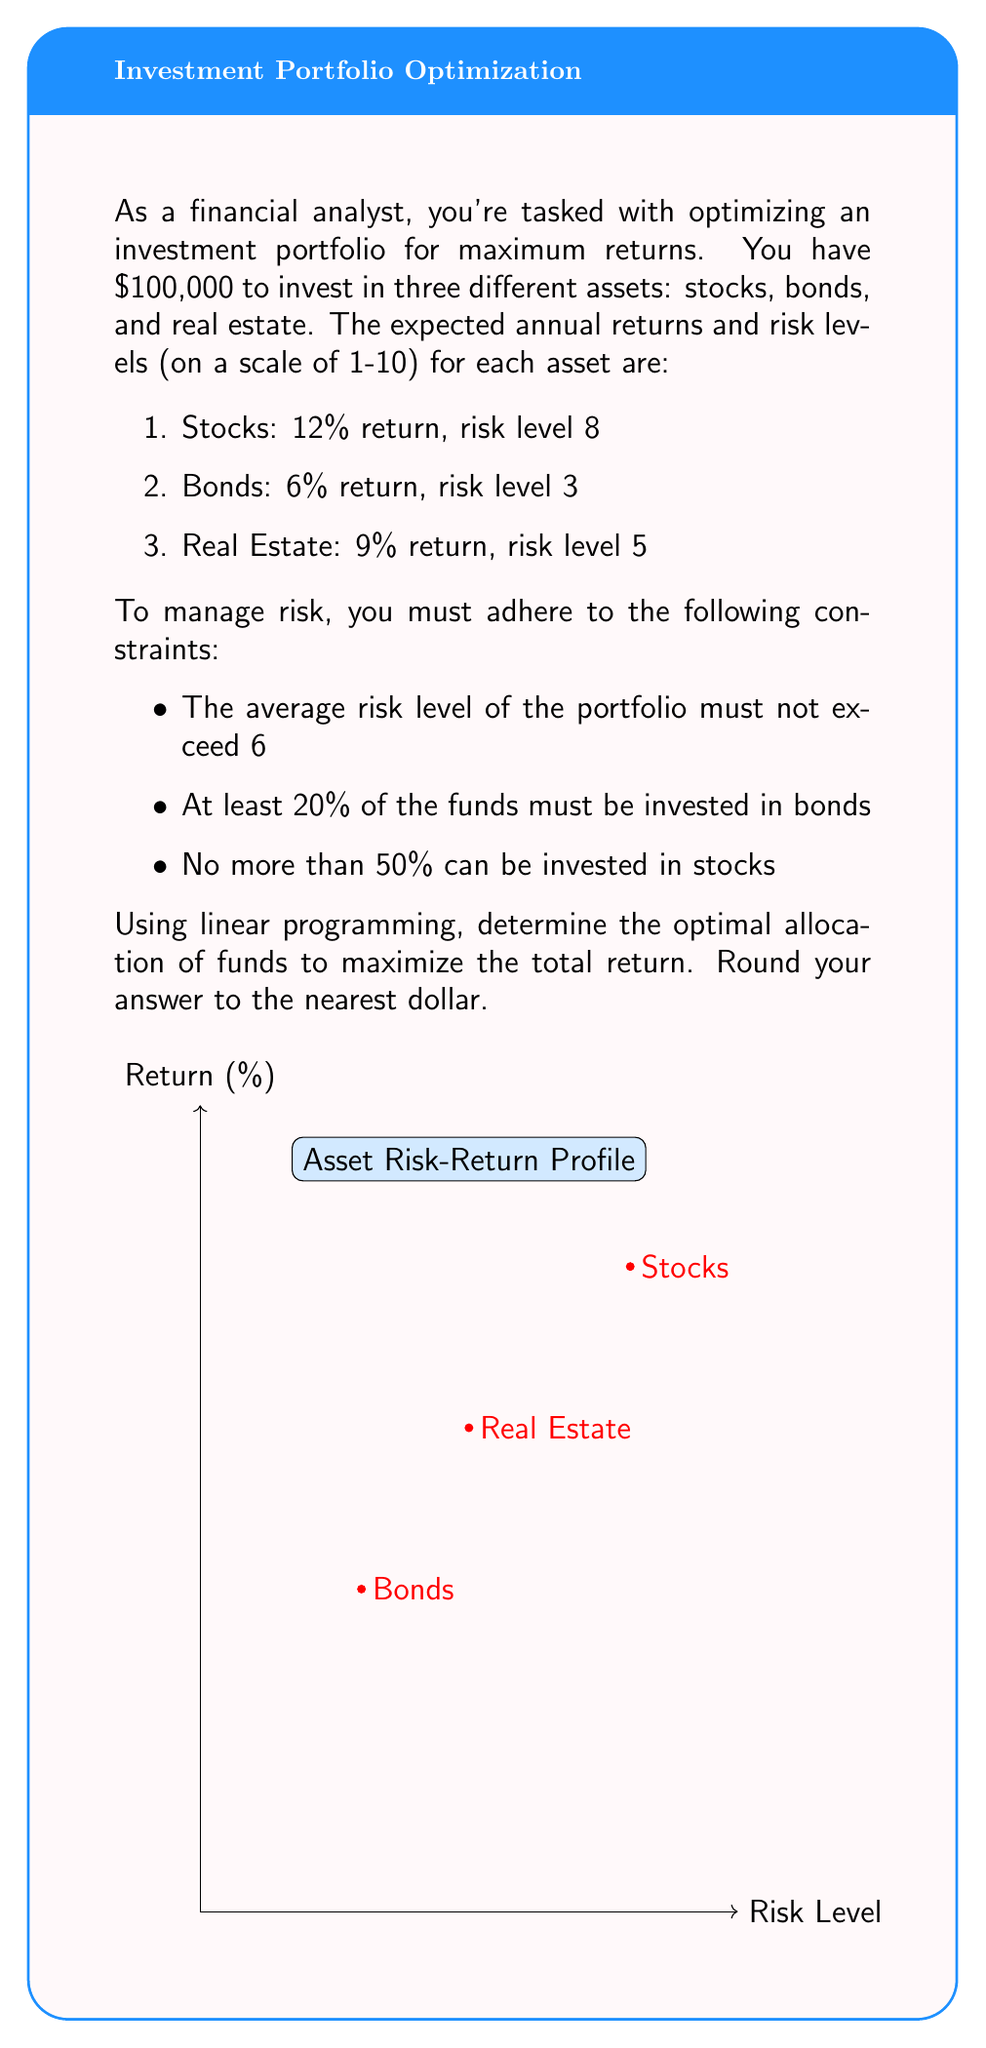Can you answer this question? Let's approach this step-by-step using linear programming:

1) Define variables:
   Let $x_1$, $x_2$, and $x_3$ be the amounts invested in stocks, bonds, and real estate respectively.

2) Objective function:
   Maximize $Z = 0.12x_1 + 0.06x_2 + 0.09x_3$

3) Constraints:
   a) Total investment: $x_1 + x_2 + x_3 = 100000$
   b) Risk level: $\frac{8x_1 + 3x_2 + 5x_3}{x_1 + x_2 + x_3} \leq 6$
      This can be rewritten as: $8x_1 + 3x_2 + 5x_3 \leq 6(x_1 + x_2 + x_3)$
      Simplifying: $2x_1 - 3x_2 - x_3 \leq 0$
   c) Minimum bonds: $x_2 \geq 0.2(100000) = 20000$
   d) Maximum stocks: $x_1 \leq 0.5(100000) = 50000$
   e) Non-negativity: $x_1, x_2, x_3 \geq 0$

4) Solve using the simplex method or linear programming software:
   The optimal solution is:
   $x_1 = 50000$ (Stocks)
   $x_2 = 20000$ (Bonds)
   $x_3 = 30000$ (Real Estate)

5) Verify constraints:
   - Total investment: $50000 + 20000 + 30000 = 100000$ (Satisfied)
   - Risk level: $\frac{8(50000) + 3(20000) + 5(30000)}{100000} = 6$ (Satisfied)
   - Minimum bonds: $20000 \geq 20000$ (Satisfied)
   - Maximum stocks: $50000 \leq 50000$ (Satisfied)

6) Calculate maximum return:
   $Z = 0.12(50000) + 0.06(20000) + 0.09(30000) = 10500$

Therefore, the maximum annual return is $10,500.
Answer: $10,500 